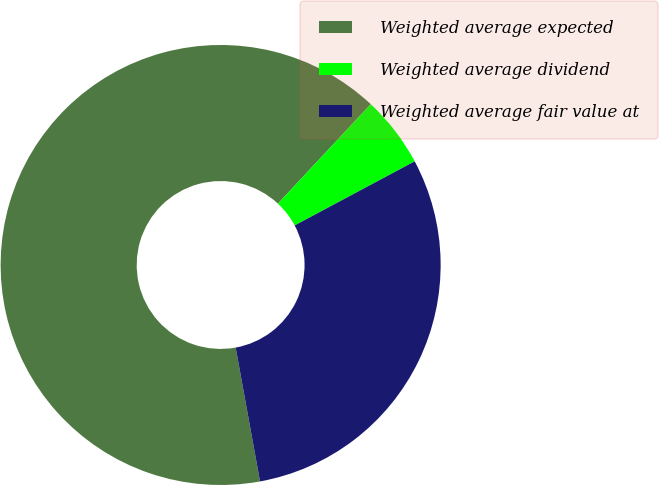<chart> <loc_0><loc_0><loc_500><loc_500><pie_chart><fcel>Weighted average expected<fcel>Weighted average dividend<fcel>Weighted average fair value at<nl><fcel>64.82%<fcel>5.24%<fcel>29.94%<nl></chart> 